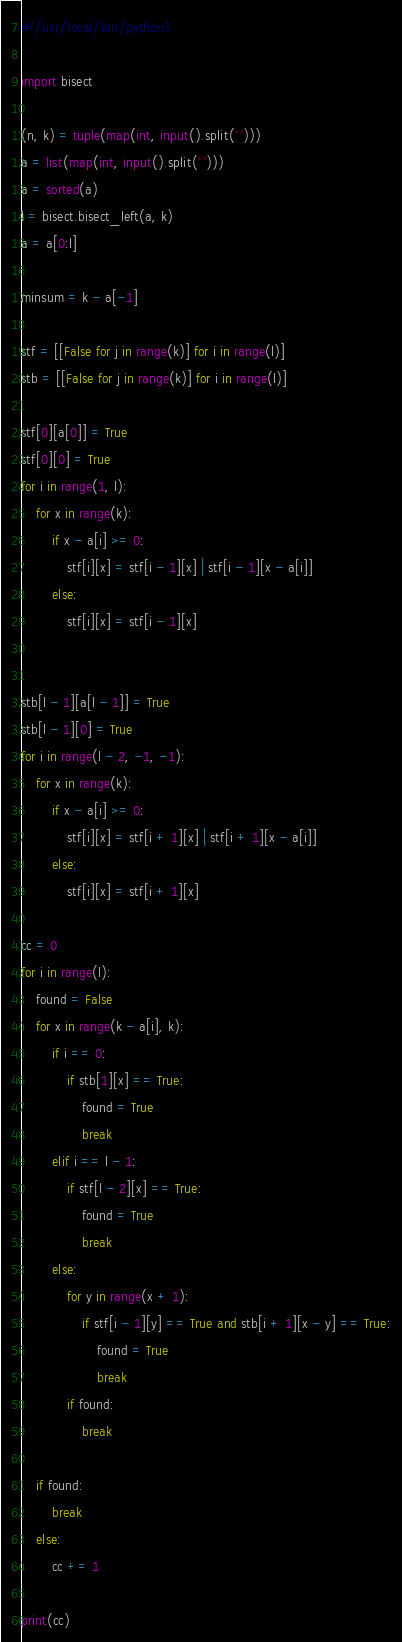Convert code to text. <code><loc_0><loc_0><loc_500><loc_500><_Python_>#!/usr/local/bin/python3

import bisect

(n, k) = tuple(map(int, input().split(' ')))
a = list(map(int, input().split(' ')))
a = sorted(a)
l = bisect.bisect_left(a, k)
a = a[0:l]

minsum = k - a[-1]

stf = [[False for j in range(k)] for i in range(l)]
stb = [[False for j in range(k)] for i in range(l)]

stf[0][a[0]] = True
stf[0][0] = True
for i in range(1, l):
    for x in range(k):
        if x - a[i] >= 0:
            stf[i][x] = stf[i - 1][x] | stf[i - 1][x - a[i]]
        else:
            stf[i][x] = stf[i - 1][x]


stb[l - 1][a[l - 1]] = True
stb[l - 1][0] = True
for i in range(l - 2, -1, -1):
    for x in range(k):
        if x - a[i] >= 0:
            stf[i][x] = stf[i + 1][x] | stf[i + 1][x - a[i]]
        else:
            stf[i][x] = stf[i + 1][x]

cc = 0
for i in range(l):
    found = False
    for x in range(k - a[i], k):
        if i == 0:
            if stb[1][x] == True:
                found = True
                break
        elif i == l - 1:
            if stf[l - 2][x] == True:
                found = True
                break
        else:
            for y in range(x + 1):
                if stf[i - 1][y] == True and stb[i + 1][x - y] == True:
                    found = True
                    break
            if found:
                break

    if found:
        break
    else:
        cc += 1
        
print(cc)
</code> 